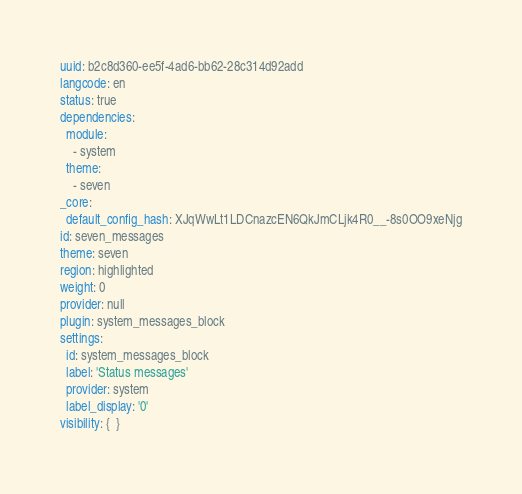Convert code to text. <code><loc_0><loc_0><loc_500><loc_500><_YAML_>uuid: b2c8d360-ee5f-4ad6-bb62-28c314d92add
langcode: en
status: true
dependencies:
  module:
    - system
  theme:
    - seven
_core:
  default_config_hash: XJqWwLt1LDCnazcEN6QkJmCLjk4R0__-8s0OO9xeNjg
id: seven_messages
theme: seven
region: highlighted
weight: 0
provider: null
plugin: system_messages_block
settings:
  id: system_messages_block
  label: 'Status messages'
  provider: system
  label_display: '0'
visibility: {  }
</code> 